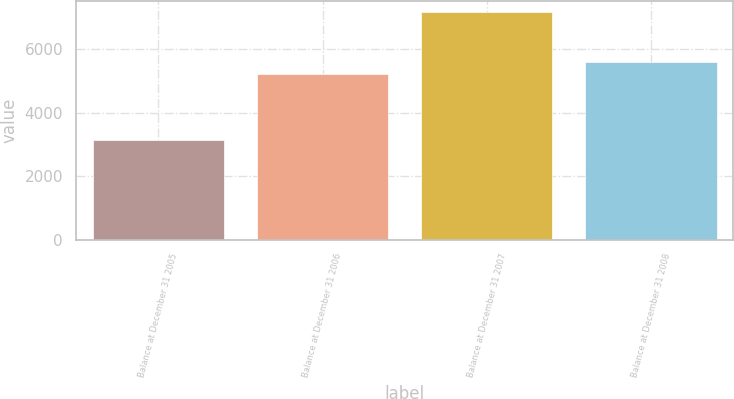<chart> <loc_0><loc_0><loc_500><loc_500><bar_chart><fcel>Balance at December 31 2005<fcel>Balance at December 31 2006<fcel>Balance at December 31 2007<fcel>Balance at December 31 2008<nl><fcel>3132<fcel>5203<fcel>7160<fcel>5605.8<nl></chart> 